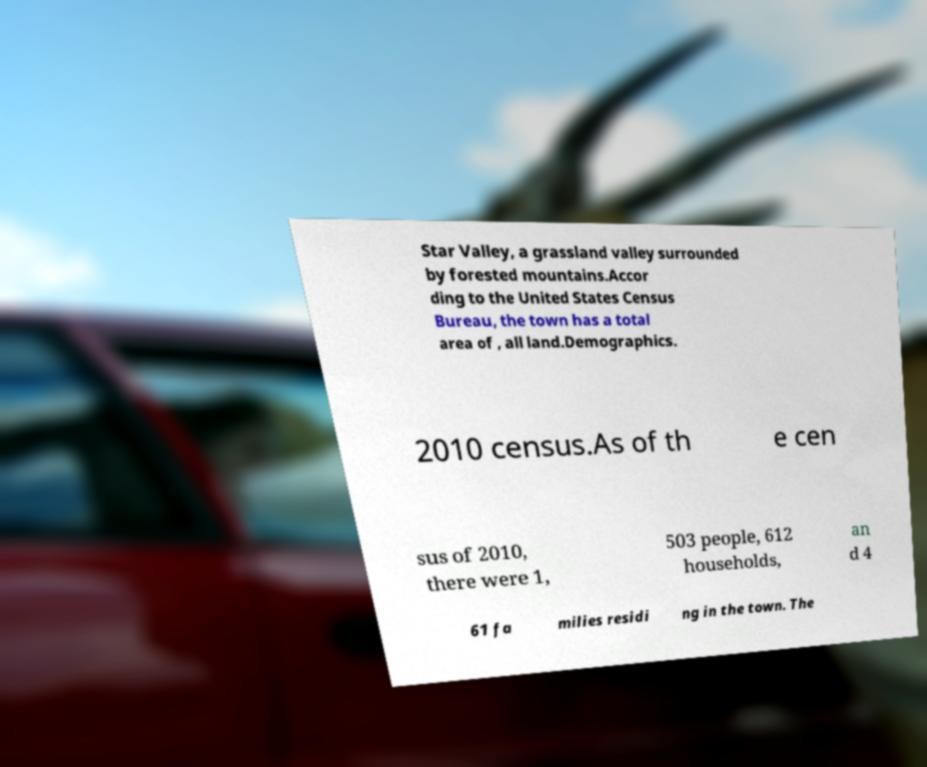For documentation purposes, I need the text within this image transcribed. Could you provide that? Star Valley, a grassland valley surrounded by forested mountains.Accor ding to the United States Census Bureau, the town has a total area of , all land.Demographics. 2010 census.As of th e cen sus of 2010, there were 1, 503 people, 612 households, an d 4 61 fa milies residi ng in the town. The 